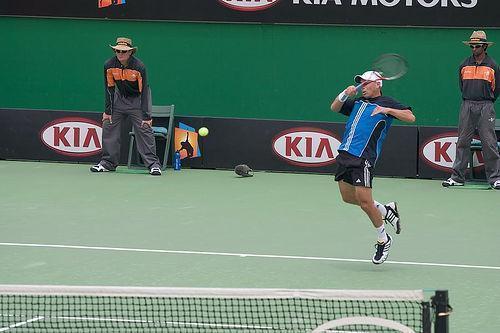What did the man in the blue shirt just do?
From the following set of four choices, select the accurate answer to respond to the question.
Options: Served, quit, missed ball, returned ball. Returned ball. 